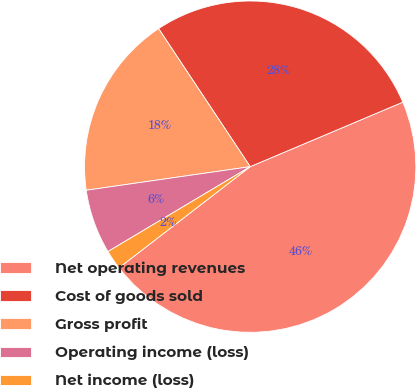Convert chart to OTSL. <chart><loc_0><loc_0><loc_500><loc_500><pie_chart><fcel>Net operating revenues<fcel>Cost of goods sold<fcel>Gross profit<fcel>Operating income (loss)<fcel>Net income (loss)<nl><fcel>45.91%<fcel>27.96%<fcel>17.95%<fcel>6.29%<fcel>1.89%<nl></chart> 